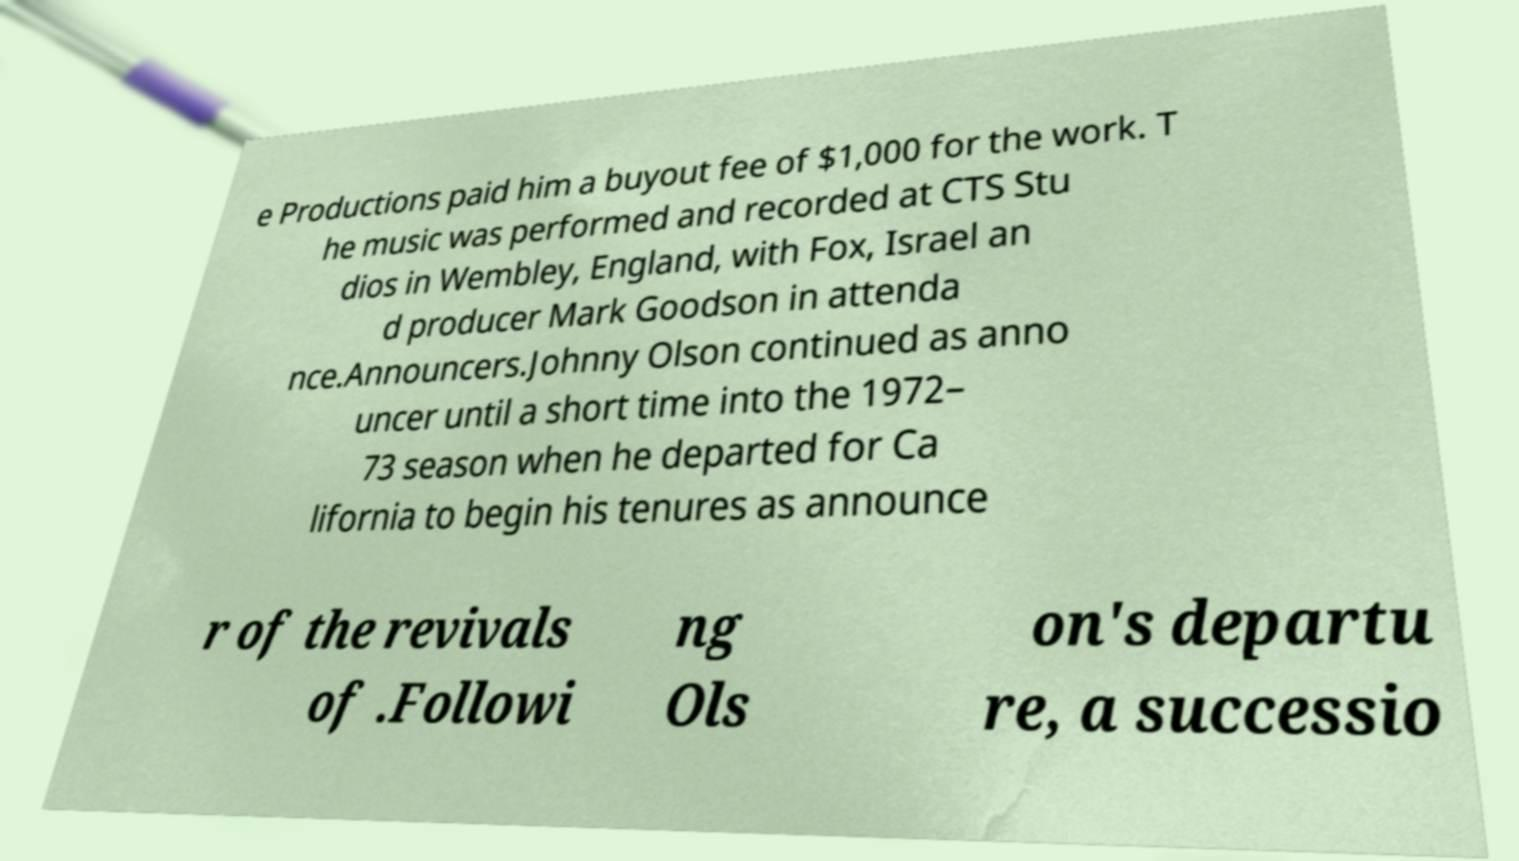Can you accurately transcribe the text from the provided image for me? e Productions paid him a buyout fee of $1,000 for the work. T he music was performed and recorded at CTS Stu dios in Wembley, England, with Fox, Israel an d producer Mark Goodson in attenda nce.Announcers.Johnny Olson continued as anno uncer until a short time into the 1972– 73 season when he departed for Ca lifornia to begin his tenures as announce r of the revivals of .Followi ng Ols on's departu re, a successio 